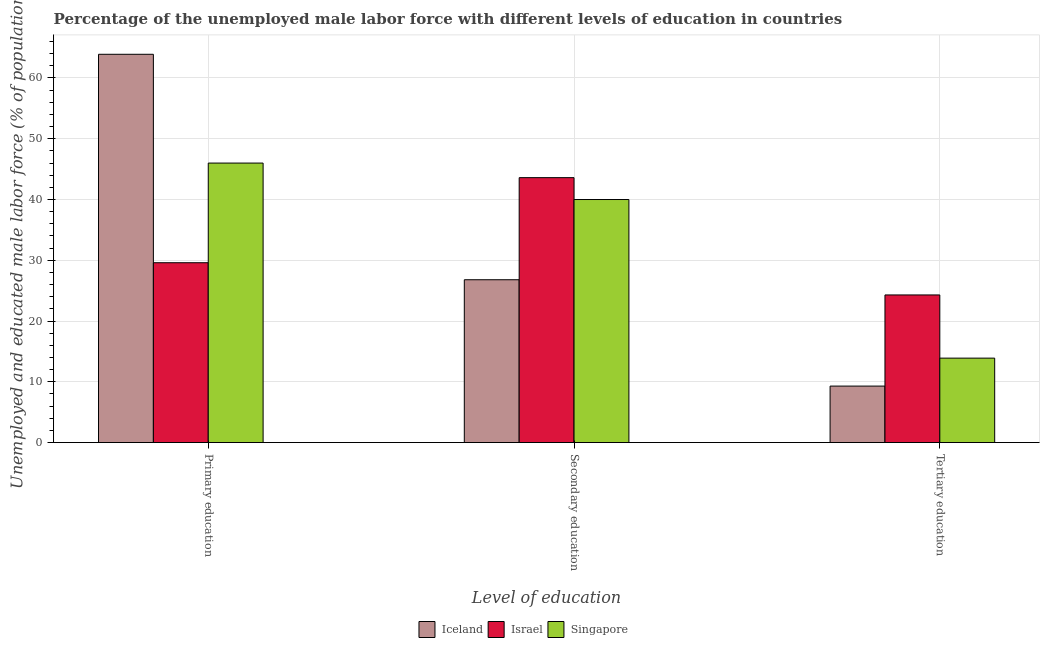How many different coloured bars are there?
Your answer should be very brief. 3. Are the number of bars per tick equal to the number of legend labels?
Provide a short and direct response. Yes. Are the number of bars on each tick of the X-axis equal?
Keep it short and to the point. Yes. How many bars are there on the 2nd tick from the right?
Your answer should be compact. 3. What is the label of the 1st group of bars from the left?
Your response must be concise. Primary education. What is the percentage of male labor force who received primary education in Singapore?
Keep it short and to the point. 46. Across all countries, what is the maximum percentage of male labor force who received primary education?
Your answer should be very brief. 63.9. Across all countries, what is the minimum percentage of male labor force who received primary education?
Ensure brevity in your answer.  29.6. What is the total percentage of male labor force who received primary education in the graph?
Make the answer very short. 139.5. What is the difference between the percentage of male labor force who received secondary education in Iceland and that in Israel?
Offer a terse response. -16.8. What is the difference between the percentage of male labor force who received primary education in Iceland and the percentage of male labor force who received secondary education in Israel?
Offer a very short reply. 20.3. What is the average percentage of male labor force who received primary education per country?
Give a very brief answer. 46.5. What is the difference between the percentage of male labor force who received secondary education and percentage of male labor force who received primary education in Singapore?
Offer a very short reply. -6. What is the ratio of the percentage of male labor force who received tertiary education in Iceland to that in Singapore?
Keep it short and to the point. 0.67. What is the difference between the highest and the second highest percentage of male labor force who received tertiary education?
Your response must be concise. 10.4. What is the difference between the highest and the lowest percentage of male labor force who received primary education?
Provide a short and direct response. 34.3. In how many countries, is the percentage of male labor force who received primary education greater than the average percentage of male labor force who received primary education taken over all countries?
Provide a short and direct response. 1. Is the sum of the percentage of male labor force who received tertiary education in Iceland and Singapore greater than the maximum percentage of male labor force who received secondary education across all countries?
Offer a terse response. No. What does the 1st bar from the right in Secondary education represents?
Offer a terse response. Singapore. Is it the case that in every country, the sum of the percentage of male labor force who received primary education and percentage of male labor force who received secondary education is greater than the percentage of male labor force who received tertiary education?
Provide a succinct answer. Yes. How many countries are there in the graph?
Offer a very short reply. 3. What is the difference between two consecutive major ticks on the Y-axis?
Provide a succinct answer. 10. Does the graph contain any zero values?
Make the answer very short. No. Does the graph contain grids?
Provide a short and direct response. Yes. Where does the legend appear in the graph?
Provide a succinct answer. Bottom center. How many legend labels are there?
Offer a terse response. 3. What is the title of the graph?
Offer a terse response. Percentage of the unemployed male labor force with different levels of education in countries. Does "Small states" appear as one of the legend labels in the graph?
Make the answer very short. No. What is the label or title of the X-axis?
Offer a terse response. Level of education. What is the label or title of the Y-axis?
Keep it short and to the point. Unemployed and educated male labor force (% of population). What is the Unemployed and educated male labor force (% of population) in Iceland in Primary education?
Your response must be concise. 63.9. What is the Unemployed and educated male labor force (% of population) of Israel in Primary education?
Provide a succinct answer. 29.6. What is the Unemployed and educated male labor force (% of population) in Singapore in Primary education?
Provide a succinct answer. 46. What is the Unemployed and educated male labor force (% of population) in Iceland in Secondary education?
Provide a short and direct response. 26.8. What is the Unemployed and educated male labor force (% of population) in Israel in Secondary education?
Offer a very short reply. 43.6. What is the Unemployed and educated male labor force (% of population) in Iceland in Tertiary education?
Give a very brief answer. 9.3. What is the Unemployed and educated male labor force (% of population) of Israel in Tertiary education?
Your response must be concise. 24.3. What is the Unemployed and educated male labor force (% of population) of Singapore in Tertiary education?
Make the answer very short. 13.9. Across all Level of education, what is the maximum Unemployed and educated male labor force (% of population) in Iceland?
Ensure brevity in your answer.  63.9. Across all Level of education, what is the maximum Unemployed and educated male labor force (% of population) of Israel?
Give a very brief answer. 43.6. Across all Level of education, what is the maximum Unemployed and educated male labor force (% of population) of Singapore?
Offer a very short reply. 46. Across all Level of education, what is the minimum Unemployed and educated male labor force (% of population) of Iceland?
Offer a terse response. 9.3. Across all Level of education, what is the minimum Unemployed and educated male labor force (% of population) of Israel?
Give a very brief answer. 24.3. Across all Level of education, what is the minimum Unemployed and educated male labor force (% of population) in Singapore?
Offer a very short reply. 13.9. What is the total Unemployed and educated male labor force (% of population) in Israel in the graph?
Provide a succinct answer. 97.5. What is the total Unemployed and educated male labor force (% of population) in Singapore in the graph?
Keep it short and to the point. 99.9. What is the difference between the Unemployed and educated male labor force (% of population) of Iceland in Primary education and that in Secondary education?
Your response must be concise. 37.1. What is the difference between the Unemployed and educated male labor force (% of population) in Singapore in Primary education and that in Secondary education?
Offer a terse response. 6. What is the difference between the Unemployed and educated male labor force (% of population) in Iceland in Primary education and that in Tertiary education?
Offer a terse response. 54.6. What is the difference between the Unemployed and educated male labor force (% of population) in Singapore in Primary education and that in Tertiary education?
Give a very brief answer. 32.1. What is the difference between the Unemployed and educated male labor force (% of population) of Israel in Secondary education and that in Tertiary education?
Provide a succinct answer. 19.3. What is the difference between the Unemployed and educated male labor force (% of population) in Singapore in Secondary education and that in Tertiary education?
Make the answer very short. 26.1. What is the difference between the Unemployed and educated male labor force (% of population) of Iceland in Primary education and the Unemployed and educated male labor force (% of population) of Israel in Secondary education?
Keep it short and to the point. 20.3. What is the difference between the Unemployed and educated male labor force (% of population) in Iceland in Primary education and the Unemployed and educated male labor force (% of population) in Singapore in Secondary education?
Offer a terse response. 23.9. What is the difference between the Unemployed and educated male labor force (% of population) in Iceland in Primary education and the Unemployed and educated male labor force (% of population) in Israel in Tertiary education?
Make the answer very short. 39.6. What is the difference between the Unemployed and educated male labor force (% of population) of Israel in Primary education and the Unemployed and educated male labor force (% of population) of Singapore in Tertiary education?
Ensure brevity in your answer.  15.7. What is the difference between the Unemployed and educated male labor force (% of population) of Iceland in Secondary education and the Unemployed and educated male labor force (% of population) of Israel in Tertiary education?
Your response must be concise. 2.5. What is the difference between the Unemployed and educated male labor force (% of population) of Iceland in Secondary education and the Unemployed and educated male labor force (% of population) of Singapore in Tertiary education?
Make the answer very short. 12.9. What is the difference between the Unemployed and educated male labor force (% of population) in Israel in Secondary education and the Unemployed and educated male labor force (% of population) in Singapore in Tertiary education?
Make the answer very short. 29.7. What is the average Unemployed and educated male labor force (% of population) in Iceland per Level of education?
Your answer should be compact. 33.33. What is the average Unemployed and educated male labor force (% of population) of Israel per Level of education?
Your answer should be compact. 32.5. What is the average Unemployed and educated male labor force (% of population) in Singapore per Level of education?
Offer a terse response. 33.3. What is the difference between the Unemployed and educated male labor force (% of population) in Iceland and Unemployed and educated male labor force (% of population) in Israel in Primary education?
Your response must be concise. 34.3. What is the difference between the Unemployed and educated male labor force (% of population) of Iceland and Unemployed and educated male labor force (% of population) of Singapore in Primary education?
Ensure brevity in your answer.  17.9. What is the difference between the Unemployed and educated male labor force (% of population) in Israel and Unemployed and educated male labor force (% of population) in Singapore in Primary education?
Your answer should be compact. -16.4. What is the difference between the Unemployed and educated male labor force (% of population) of Iceland and Unemployed and educated male labor force (% of population) of Israel in Secondary education?
Give a very brief answer. -16.8. What is the difference between the Unemployed and educated male labor force (% of population) of Israel and Unemployed and educated male labor force (% of population) of Singapore in Secondary education?
Ensure brevity in your answer.  3.6. What is the difference between the Unemployed and educated male labor force (% of population) of Iceland and Unemployed and educated male labor force (% of population) of Singapore in Tertiary education?
Your answer should be very brief. -4.6. What is the ratio of the Unemployed and educated male labor force (% of population) of Iceland in Primary education to that in Secondary education?
Keep it short and to the point. 2.38. What is the ratio of the Unemployed and educated male labor force (% of population) in Israel in Primary education to that in Secondary education?
Give a very brief answer. 0.68. What is the ratio of the Unemployed and educated male labor force (% of population) of Singapore in Primary education to that in Secondary education?
Make the answer very short. 1.15. What is the ratio of the Unemployed and educated male labor force (% of population) in Iceland in Primary education to that in Tertiary education?
Make the answer very short. 6.87. What is the ratio of the Unemployed and educated male labor force (% of population) in Israel in Primary education to that in Tertiary education?
Provide a short and direct response. 1.22. What is the ratio of the Unemployed and educated male labor force (% of population) of Singapore in Primary education to that in Tertiary education?
Your answer should be compact. 3.31. What is the ratio of the Unemployed and educated male labor force (% of population) in Iceland in Secondary education to that in Tertiary education?
Your answer should be compact. 2.88. What is the ratio of the Unemployed and educated male labor force (% of population) of Israel in Secondary education to that in Tertiary education?
Ensure brevity in your answer.  1.79. What is the ratio of the Unemployed and educated male labor force (% of population) in Singapore in Secondary education to that in Tertiary education?
Your answer should be compact. 2.88. What is the difference between the highest and the second highest Unemployed and educated male labor force (% of population) of Iceland?
Give a very brief answer. 37.1. What is the difference between the highest and the second highest Unemployed and educated male labor force (% of population) in Israel?
Provide a succinct answer. 14. What is the difference between the highest and the lowest Unemployed and educated male labor force (% of population) in Iceland?
Provide a succinct answer. 54.6. What is the difference between the highest and the lowest Unemployed and educated male labor force (% of population) of Israel?
Your answer should be very brief. 19.3. What is the difference between the highest and the lowest Unemployed and educated male labor force (% of population) in Singapore?
Offer a very short reply. 32.1. 